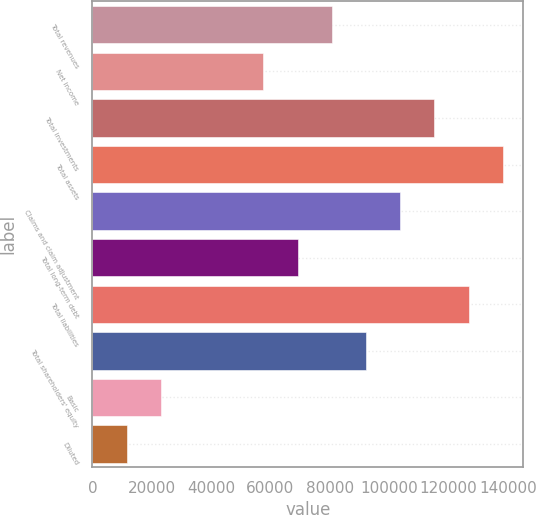<chart> <loc_0><loc_0><loc_500><loc_500><bar_chart><fcel>Total revenues<fcel>Net income<fcel>Total investments<fcel>Total assets<fcel>Claims and claim adjustment<fcel>Total long-term debt<fcel>Total liabilities<fcel>Total shareholders' equity<fcel>Basic<fcel>Diluted<nl><fcel>80704.7<fcel>57646.5<fcel>115292<fcel>138350<fcel>103763<fcel>69175.6<fcel>126821<fcel>92233.8<fcel>23059.2<fcel>11530.1<nl></chart> 